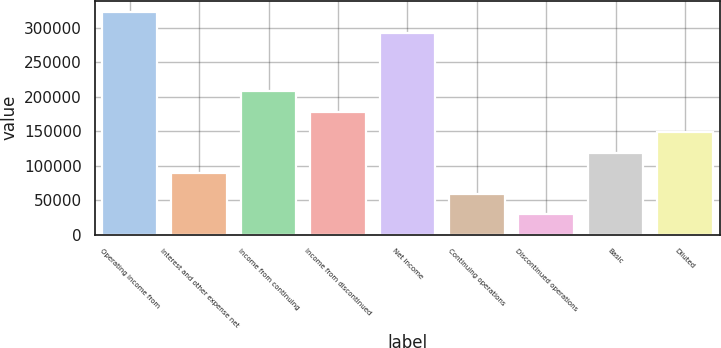Convert chart. <chart><loc_0><loc_0><loc_500><loc_500><bar_chart><fcel>Operating income from<fcel>Interest and other expense net<fcel>Income from continuing<fcel>Income from discontinued<fcel>Net income<fcel>Continuing operations<fcel>Discontinued operations<fcel>Basic<fcel>Diluted<nl><fcel>322305<fcel>89015.6<fcel>207703<fcel>178031<fcel>292633<fcel>59343.8<fcel>29672<fcel>118687<fcel>148359<nl></chart> 